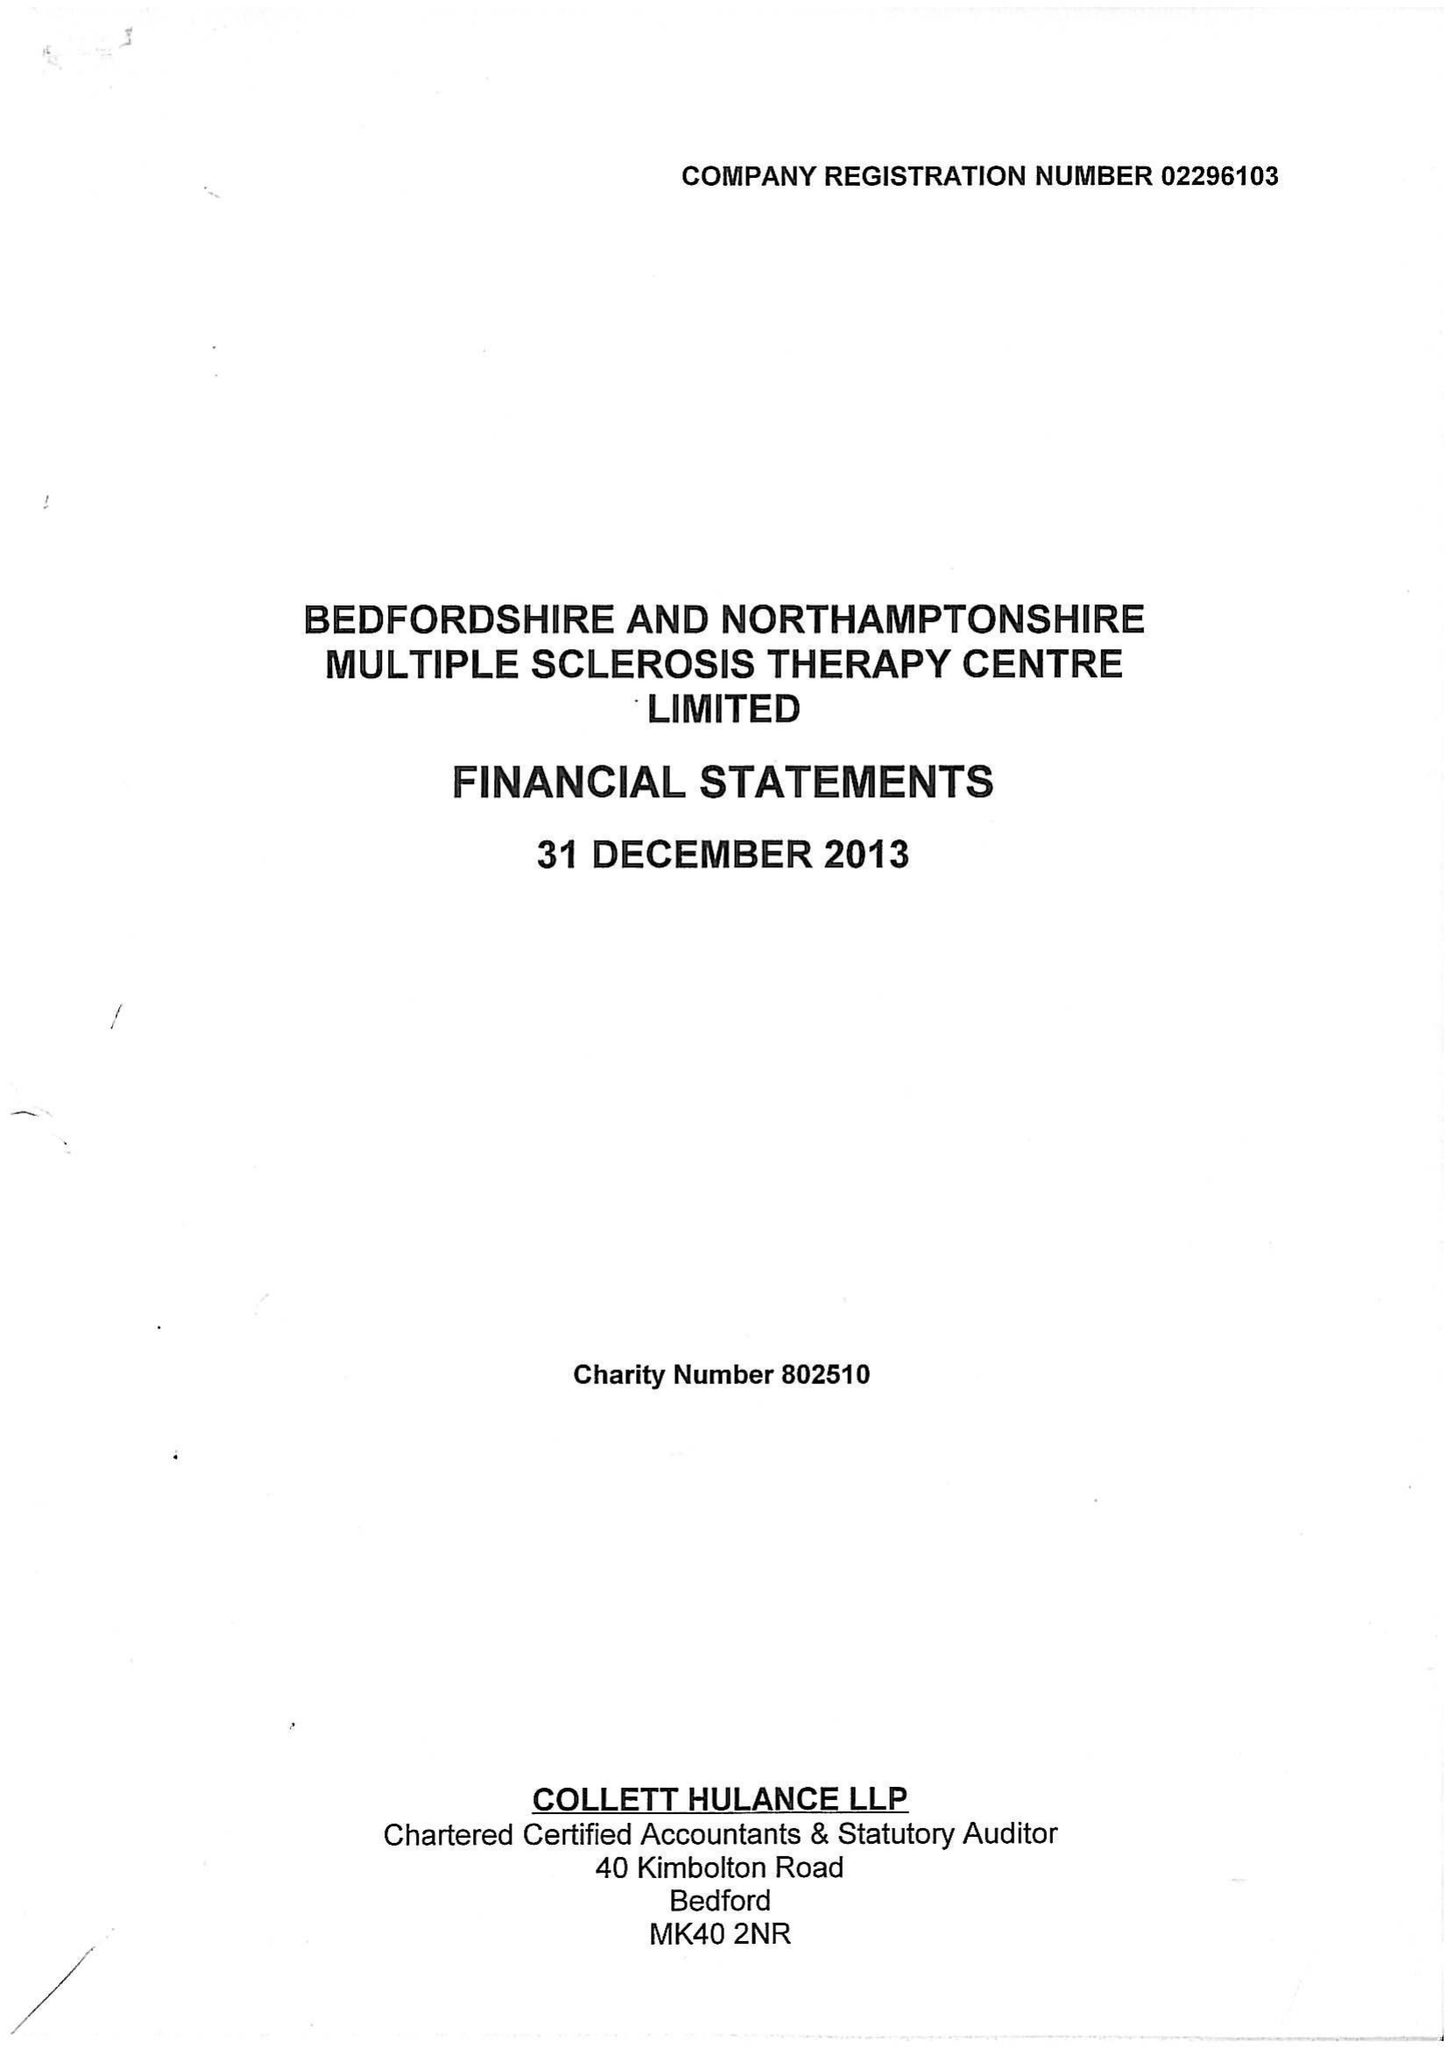What is the value for the report_date?
Answer the question using a single word or phrase. 2013-12-31 